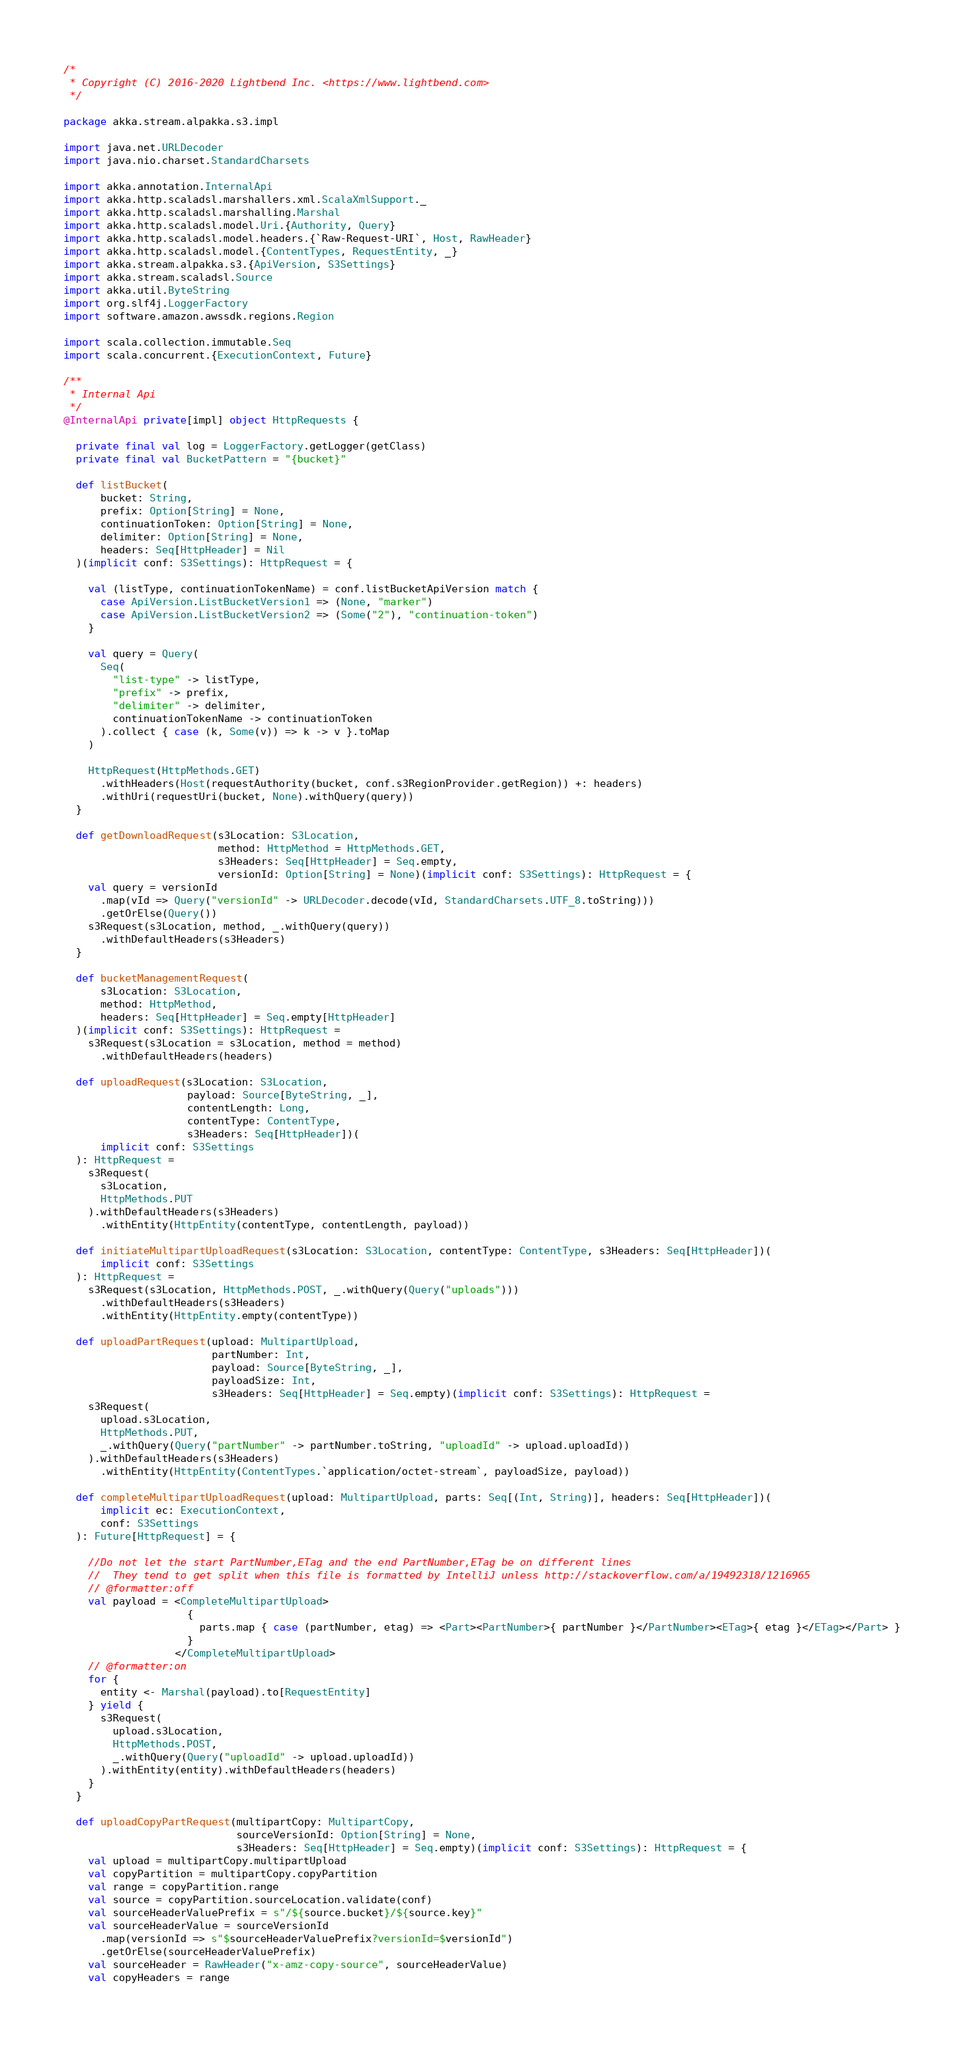Convert code to text. <code><loc_0><loc_0><loc_500><loc_500><_Scala_>/*
 * Copyright (C) 2016-2020 Lightbend Inc. <https://www.lightbend.com>
 */

package akka.stream.alpakka.s3.impl

import java.net.URLDecoder
import java.nio.charset.StandardCharsets

import akka.annotation.InternalApi
import akka.http.scaladsl.marshallers.xml.ScalaXmlSupport._
import akka.http.scaladsl.marshalling.Marshal
import akka.http.scaladsl.model.Uri.{Authority, Query}
import akka.http.scaladsl.model.headers.{`Raw-Request-URI`, Host, RawHeader}
import akka.http.scaladsl.model.{ContentTypes, RequestEntity, _}
import akka.stream.alpakka.s3.{ApiVersion, S3Settings}
import akka.stream.scaladsl.Source
import akka.util.ByteString
import org.slf4j.LoggerFactory
import software.amazon.awssdk.regions.Region

import scala.collection.immutable.Seq
import scala.concurrent.{ExecutionContext, Future}

/**
 * Internal Api
 */
@InternalApi private[impl] object HttpRequests {

  private final val log = LoggerFactory.getLogger(getClass)
  private final val BucketPattern = "{bucket}"

  def listBucket(
      bucket: String,
      prefix: Option[String] = None,
      continuationToken: Option[String] = None,
      delimiter: Option[String] = None,
      headers: Seq[HttpHeader] = Nil
  )(implicit conf: S3Settings): HttpRequest = {

    val (listType, continuationTokenName) = conf.listBucketApiVersion match {
      case ApiVersion.ListBucketVersion1 => (None, "marker")
      case ApiVersion.ListBucketVersion2 => (Some("2"), "continuation-token")
    }

    val query = Query(
      Seq(
        "list-type" -> listType,
        "prefix" -> prefix,
        "delimiter" -> delimiter,
        continuationTokenName -> continuationToken
      ).collect { case (k, Some(v)) => k -> v }.toMap
    )

    HttpRequest(HttpMethods.GET)
      .withHeaders(Host(requestAuthority(bucket, conf.s3RegionProvider.getRegion)) +: headers)
      .withUri(requestUri(bucket, None).withQuery(query))
  }

  def getDownloadRequest(s3Location: S3Location,
                         method: HttpMethod = HttpMethods.GET,
                         s3Headers: Seq[HttpHeader] = Seq.empty,
                         versionId: Option[String] = None)(implicit conf: S3Settings): HttpRequest = {
    val query = versionId
      .map(vId => Query("versionId" -> URLDecoder.decode(vId, StandardCharsets.UTF_8.toString)))
      .getOrElse(Query())
    s3Request(s3Location, method, _.withQuery(query))
      .withDefaultHeaders(s3Headers)
  }

  def bucketManagementRequest(
      s3Location: S3Location,
      method: HttpMethod,
      headers: Seq[HttpHeader] = Seq.empty[HttpHeader]
  )(implicit conf: S3Settings): HttpRequest =
    s3Request(s3Location = s3Location, method = method)
      .withDefaultHeaders(headers)

  def uploadRequest(s3Location: S3Location,
                    payload: Source[ByteString, _],
                    contentLength: Long,
                    contentType: ContentType,
                    s3Headers: Seq[HttpHeader])(
      implicit conf: S3Settings
  ): HttpRequest =
    s3Request(
      s3Location,
      HttpMethods.PUT
    ).withDefaultHeaders(s3Headers)
      .withEntity(HttpEntity(contentType, contentLength, payload))

  def initiateMultipartUploadRequest(s3Location: S3Location, contentType: ContentType, s3Headers: Seq[HttpHeader])(
      implicit conf: S3Settings
  ): HttpRequest =
    s3Request(s3Location, HttpMethods.POST, _.withQuery(Query("uploads")))
      .withDefaultHeaders(s3Headers)
      .withEntity(HttpEntity.empty(contentType))

  def uploadPartRequest(upload: MultipartUpload,
                        partNumber: Int,
                        payload: Source[ByteString, _],
                        payloadSize: Int,
                        s3Headers: Seq[HttpHeader] = Seq.empty)(implicit conf: S3Settings): HttpRequest =
    s3Request(
      upload.s3Location,
      HttpMethods.PUT,
      _.withQuery(Query("partNumber" -> partNumber.toString, "uploadId" -> upload.uploadId))
    ).withDefaultHeaders(s3Headers)
      .withEntity(HttpEntity(ContentTypes.`application/octet-stream`, payloadSize, payload))

  def completeMultipartUploadRequest(upload: MultipartUpload, parts: Seq[(Int, String)], headers: Seq[HttpHeader])(
      implicit ec: ExecutionContext,
      conf: S3Settings
  ): Future[HttpRequest] = {

    //Do not let the start PartNumber,ETag and the end PartNumber,ETag be on different lines
    //  They tend to get split when this file is formatted by IntelliJ unless http://stackoverflow.com/a/19492318/1216965
    // @formatter:off
    val payload = <CompleteMultipartUpload>
                    {
                      parts.map { case (partNumber, etag) => <Part><PartNumber>{ partNumber }</PartNumber><ETag>{ etag }</ETag></Part> }
                    }
                  </CompleteMultipartUpload>
    // @formatter:on
    for {
      entity <- Marshal(payload).to[RequestEntity]
    } yield {
      s3Request(
        upload.s3Location,
        HttpMethods.POST,
        _.withQuery(Query("uploadId" -> upload.uploadId))
      ).withEntity(entity).withDefaultHeaders(headers)
    }
  }

  def uploadCopyPartRequest(multipartCopy: MultipartCopy,
                            sourceVersionId: Option[String] = None,
                            s3Headers: Seq[HttpHeader] = Seq.empty)(implicit conf: S3Settings): HttpRequest = {
    val upload = multipartCopy.multipartUpload
    val copyPartition = multipartCopy.copyPartition
    val range = copyPartition.range
    val source = copyPartition.sourceLocation.validate(conf)
    val sourceHeaderValuePrefix = s"/${source.bucket}/${source.key}"
    val sourceHeaderValue = sourceVersionId
      .map(versionId => s"$sourceHeaderValuePrefix?versionId=$versionId")
      .getOrElse(sourceHeaderValuePrefix)
    val sourceHeader = RawHeader("x-amz-copy-source", sourceHeaderValue)
    val copyHeaders = range</code> 